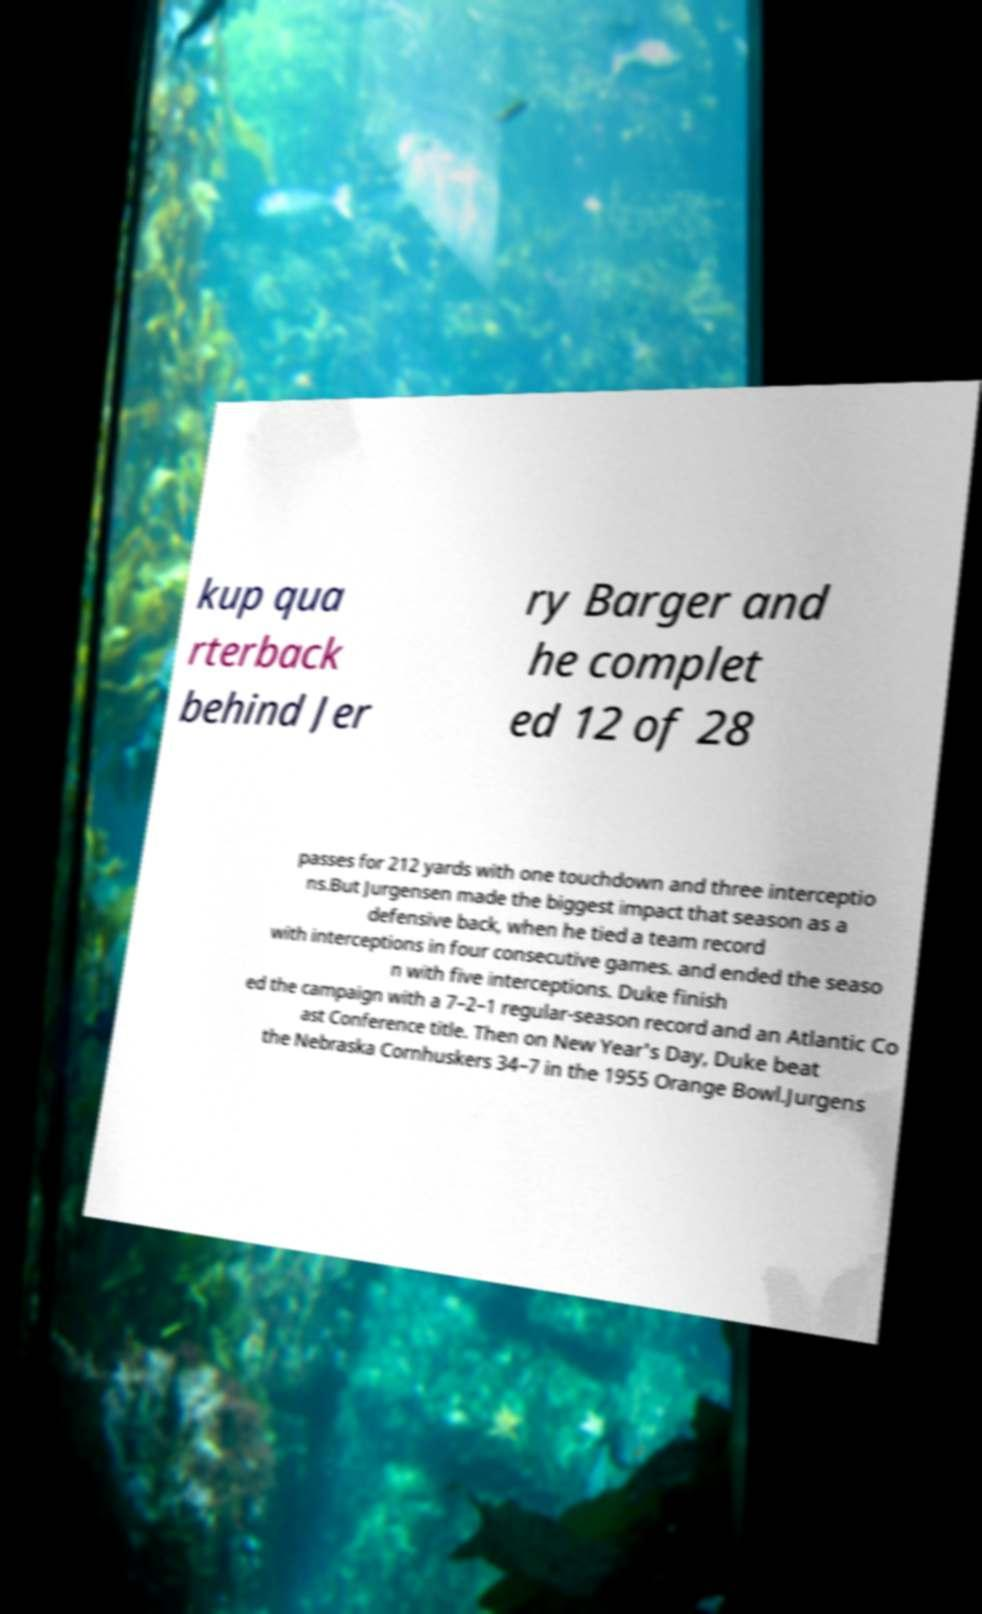Please read and relay the text visible in this image. What does it say? kup qua rterback behind Jer ry Barger and he complet ed 12 of 28 passes for 212 yards with one touchdown and three interceptio ns.But Jurgensen made the biggest impact that season as a defensive back, when he tied a team record with interceptions in four consecutive games. and ended the seaso n with five interceptions. Duke finish ed the campaign with a 7–2–1 regular-season record and an Atlantic Co ast Conference title. Then on New Year's Day, Duke beat the Nebraska Cornhuskers 34–7 in the 1955 Orange Bowl.Jurgens 